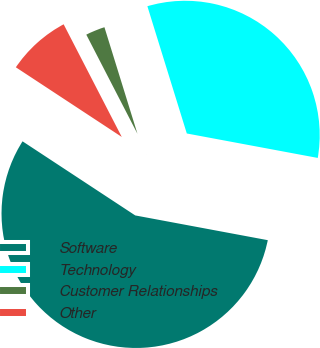<chart> <loc_0><loc_0><loc_500><loc_500><pie_chart><fcel>Software<fcel>Technology<fcel>Customer Relationships<fcel>Other<nl><fcel>56.32%<fcel>32.72%<fcel>2.8%<fcel>8.16%<nl></chart> 